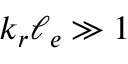Convert formula to latex. <formula><loc_0><loc_0><loc_500><loc_500>k _ { r } \ell _ { e } \gg 1</formula> 